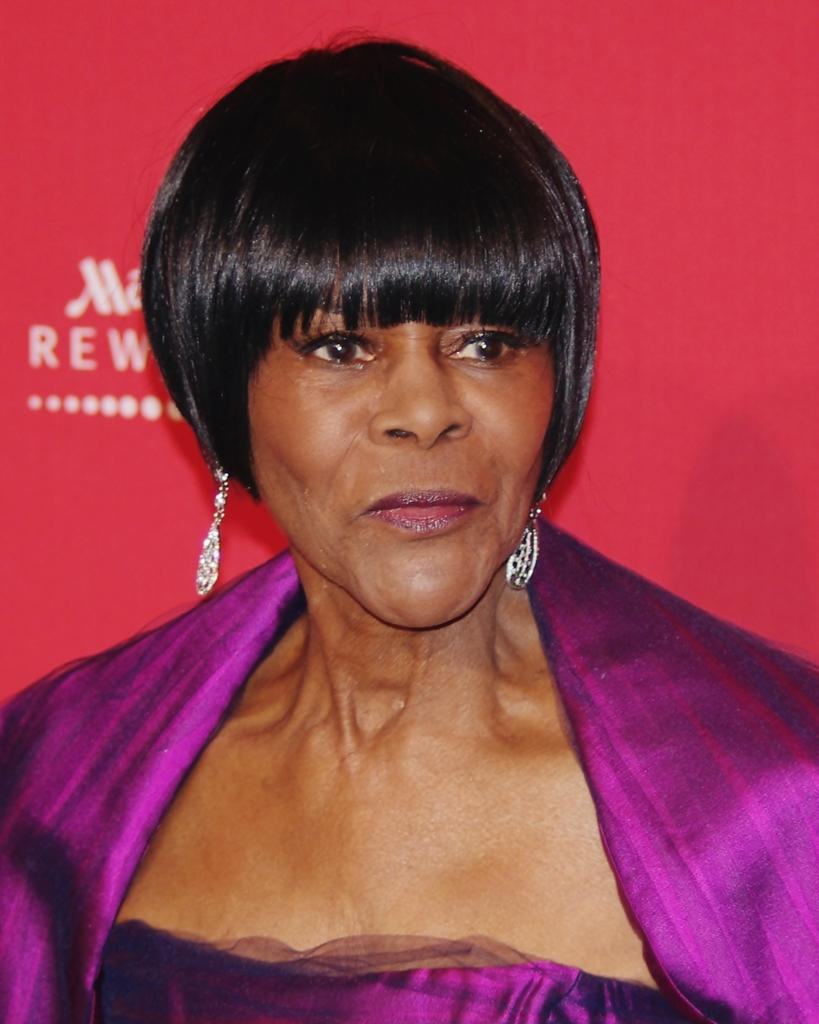Who is the main subject in the image? There is a woman in the center of the image. What can be seen in the background of the image? There is a red color curtain in the background of the image. Is there any text on the curtain? Yes, there is some text written on the curtain. What type of butter is being used in the pan in the image? There is no butter or pan present in the image. What show is the woman performing in the image? The image does not provide any information about a show or performance. 